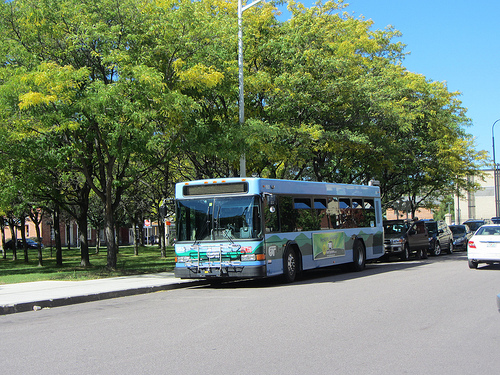What vehicle is on the left of the person? The vehicle on the left of the person is a bus. 